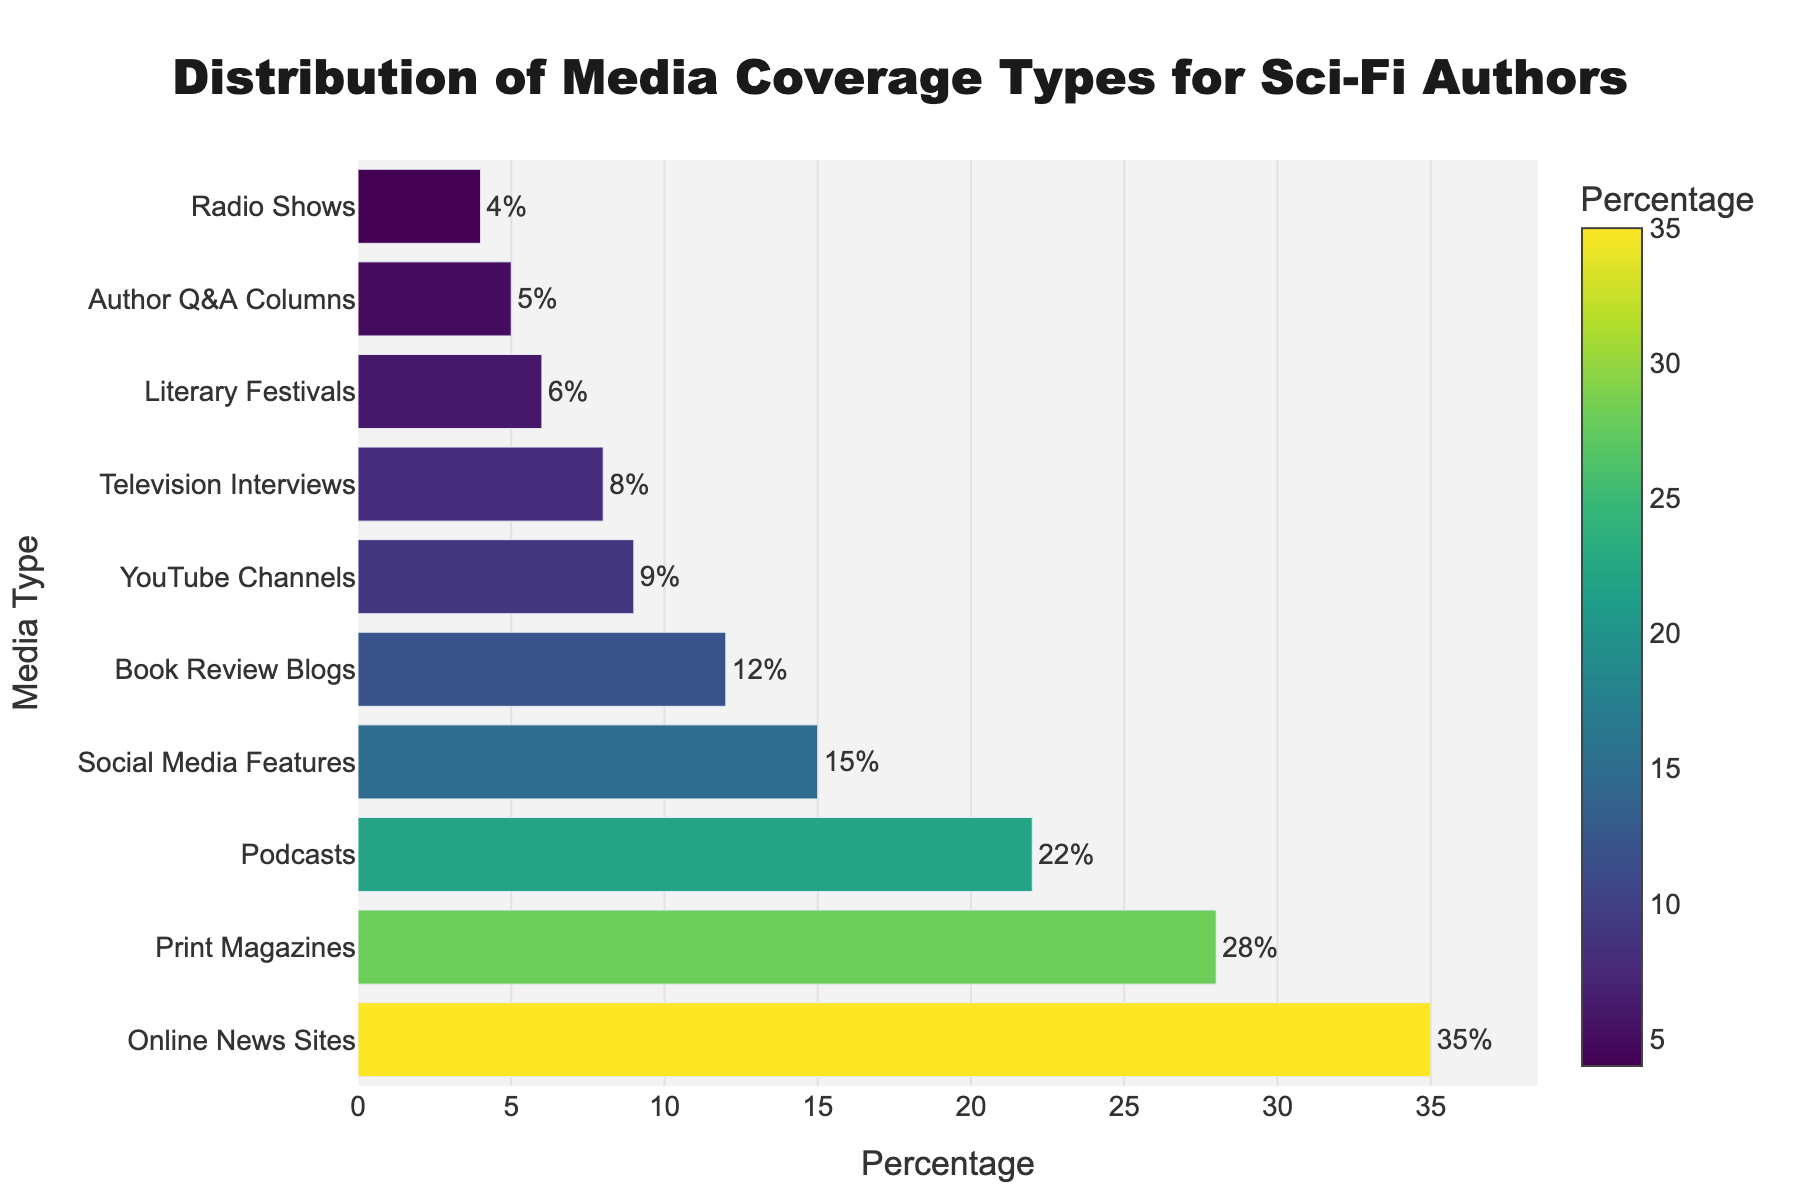Which media type has the highest distribution percentage? To find the media type with the highest distribution percentage, look for the bar with the greatest length on the chart. The "Online News Sites" bar is the longest, showing 35%.
Answer: Online News Sites Which media type has the lowest distribution percentage? To find the media type with the lowest distribution percentage, look for the shortest bar on the chart. The "Radio Shows" bar is the shortest, showing 4%.
Answer: Radio Shows What is the difference in percentage between Print Magazines and YouTube Channels? First, find the percentages for Print Magazines (28%) and YouTube Channels (9%) from the chart. Then, subtract the smaller percentage from the larger one: 28% - 9% = 19%.
Answer: 19% What is the combined percentage of Social Media Features and Book Review Blogs? From the chart, find the percentages for Social Media Features (15%) and Book Review Blogs (12%). Then, add them together: 15% + 12% = 27%.
Answer: 27% Which media type is more common, Podcasts or Television Interviews, and by how much? To compare the percentages of Podcasts (22%) and Television Interviews (8%), subtract the smaller percentage from the larger one: 22% - 8% = 14%. Podcasts are more common by 14%.
Answer: Podcasts, 14% How many media types have percentages greater than 10%? Identify the media types from the chart that have percentages above 10%: Print Magazines (28%), Online News Sites (35%), Podcasts (22%), Book Review Blogs (12%), and Social Media Features (15%). There are 5 media types in total.
Answer: 5 What is the total percentage covered by all media types shown? Sum the percentages of all media types from the chart: 28% + 35% + 22% + 8% + 4% + 12% + 6% + 15% + 9% + 5% = 144%.
Answer: 144% What is the average percentage of all media types? First, sum the percentages of all media types: 28% + 35% + 22% + 8% + 4% + 12% + 6% + 15% + 9% + 5% = 144%. Then, divide by the number of media types (10): 144% / 10 = 14.4%.
Answer: 14.4% Which media type group contributes to less than 10% combined? Find and sum the percentages of media types with less than 10% each: Television Interviews (8%), Radio Shows (4%), Literary Festivals (6%), Author Q&A Columns (5%) add up to 8% + 4% + 6% + 5% = 23%.
Answer: Television, Radio, Literary Festivals, Author Q&A Columns, 23% What is the ratio of Online News Sites coverage to Television Interviews coverage? From the chart, find the percentages for Online News Sites (35%) and Television Interviews (8%). Then calculate the ratio: 35 / 8 ≈ 4.38.
Answer: 4.38 